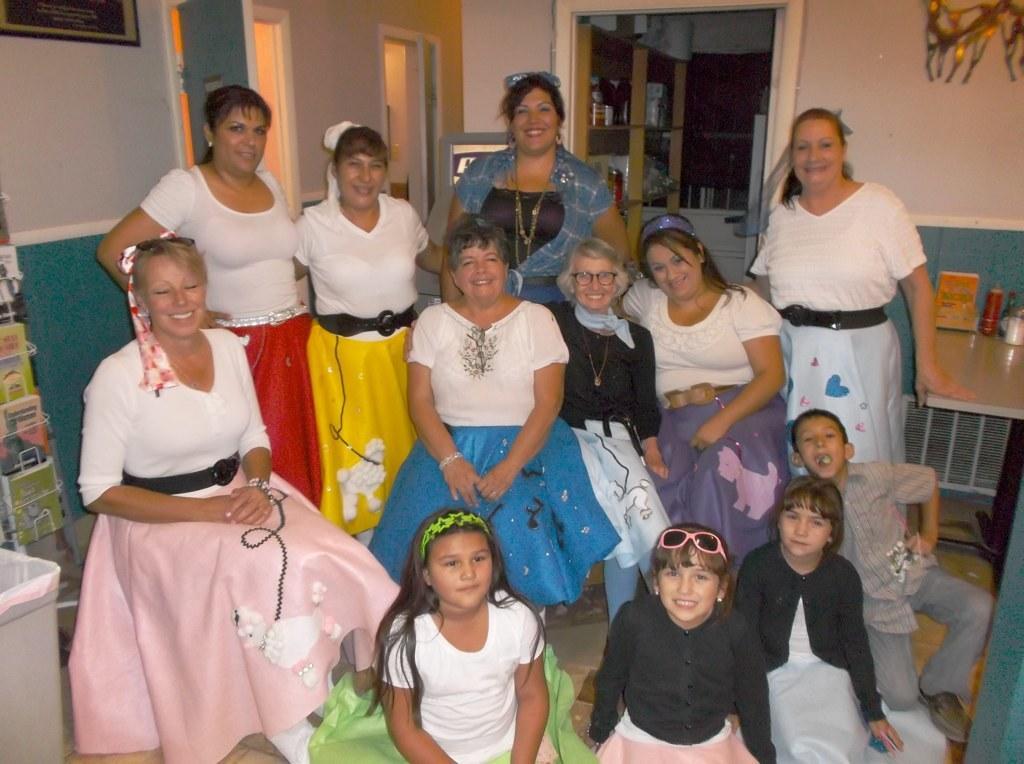In one or two sentences, can you explain what this image depicts? In this image there are group of persons sitting and standing and smiling. In the background there are doors and there is a frame on the wall. On the right side there is a table which is white in colour, on the table there are objects. On the left side there is a book stand and there are books in the stand. In the background there is a self and on the shelf there are objects. 